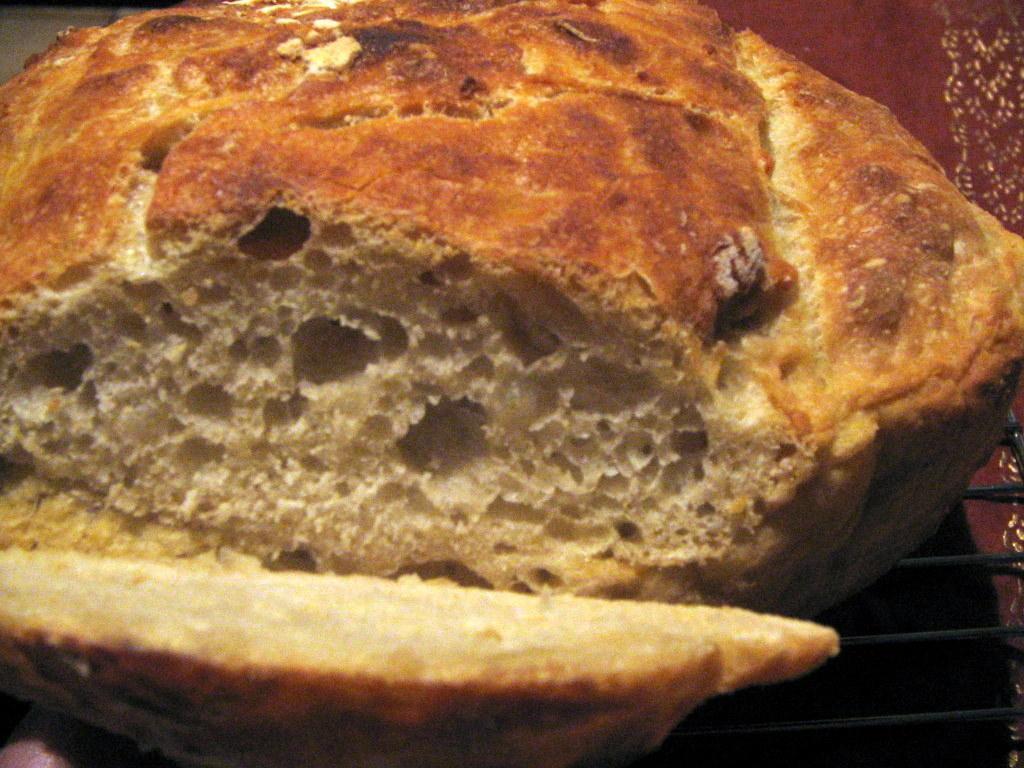Can you describe this image briefly? In this image there is a food item. 